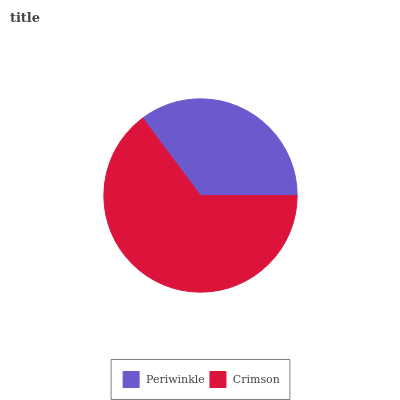Is Periwinkle the minimum?
Answer yes or no. Yes. Is Crimson the maximum?
Answer yes or no. Yes. Is Crimson the minimum?
Answer yes or no. No. Is Crimson greater than Periwinkle?
Answer yes or no. Yes. Is Periwinkle less than Crimson?
Answer yes or no. Yes. Is Periwinkle greater than Crimson?
Answer yes or no. No. Is Crimson less than Periwinkle?
Answer yes or no. No. Is Crimson the high median?
Answer yes or no. Yes. Is Periwinkle the low median?
Answer yes or no. Yes. Is Periwinkle the high median?
Answer yes or no. No. Is Crimson the low median?
Answer yes or no. No. 